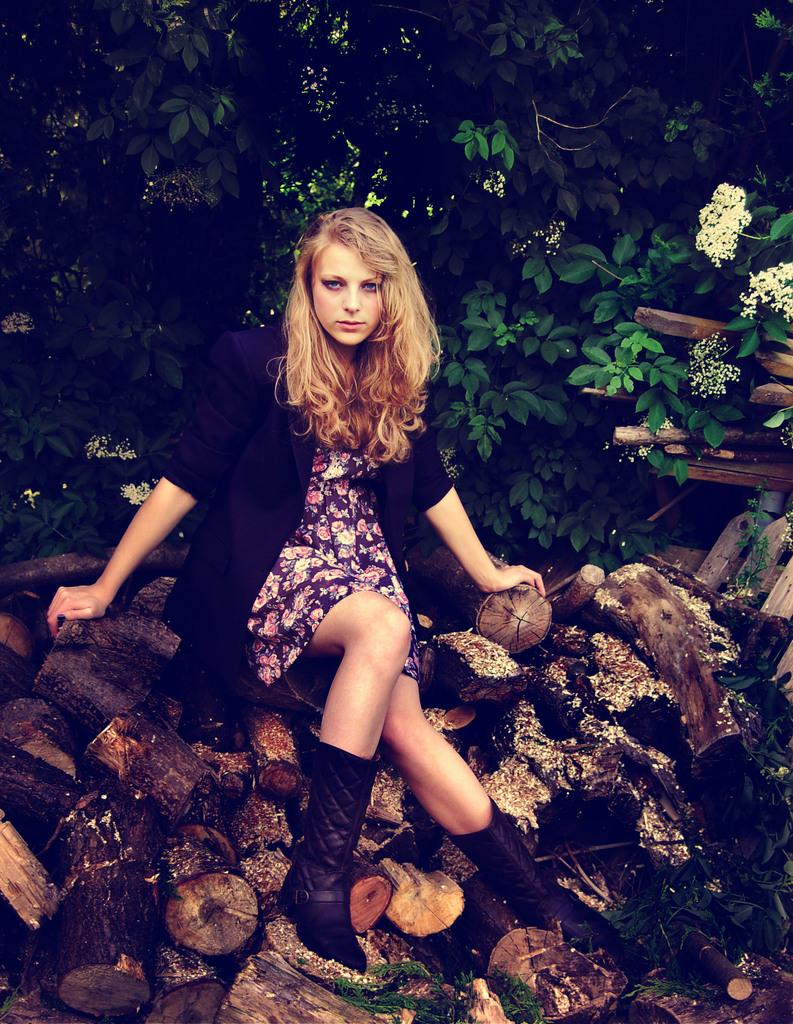What is the person in the image doing? There is a person sitting in the image. What is the person sitting on? The person is sitting on cut woods. What can be seen at the top of the image? There is a tree at the top of the image. Can you see any goldfish swimming in the image? There are no goldfish present in the image. What type of drop can be seen falling from the tree in the image? There is no drop visible falling from the tree in the image. 